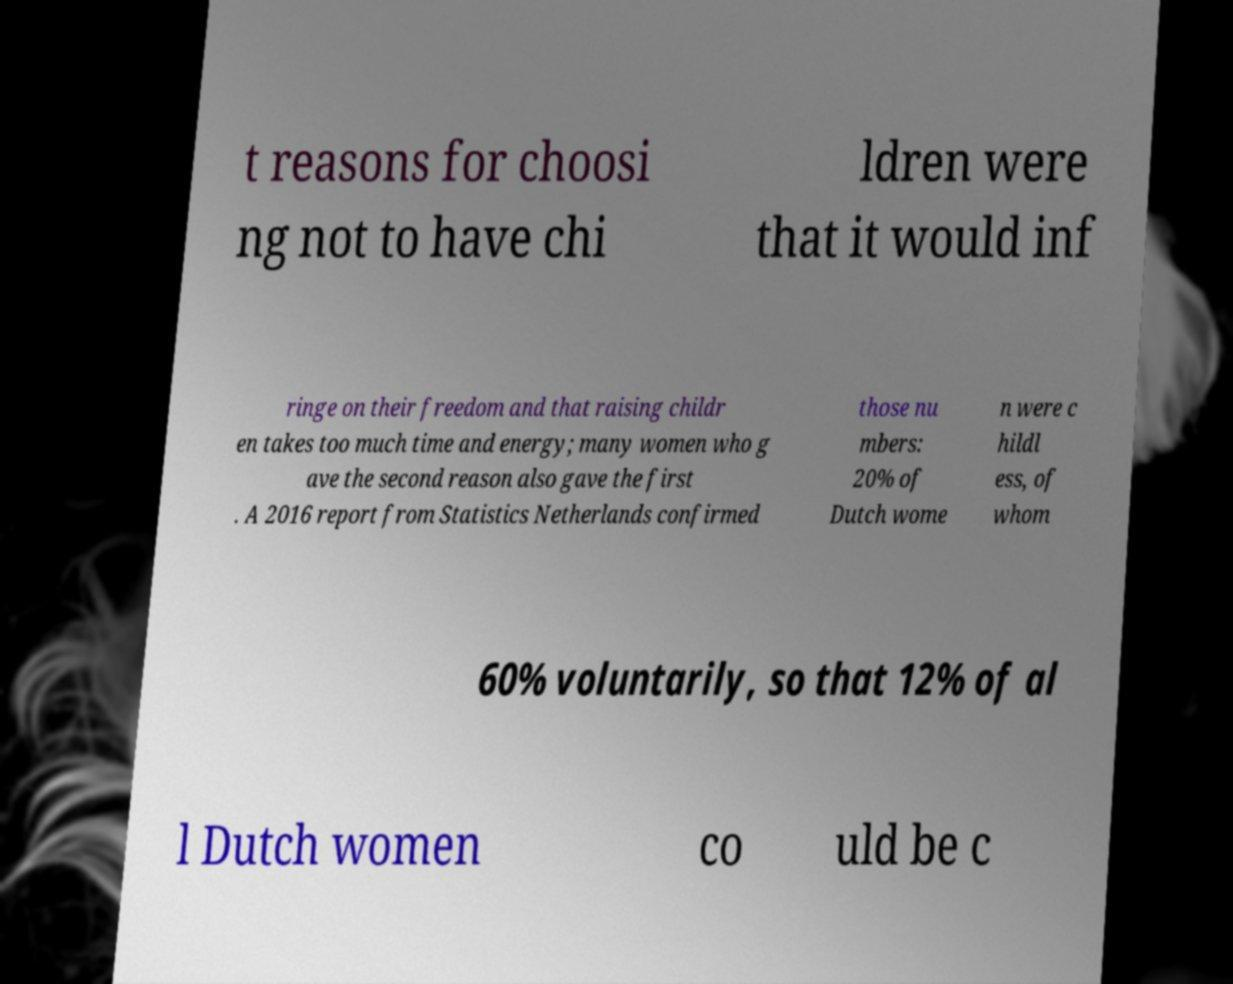Could you assist in decoding the text presented in this image and type it out clearly? t reasons for choosi ng not to have chi ldren were that it would inf ringe on their freedom and that raising childr en takes too much time and energy; many women who g ave the second reason also gave the first . A 2016 report from Statistics Netherlands confirmed those nu mbers: 20% of Dutch wome n were c hildl ess, of whom 60% voluntarily, so that 12% of al l Dutch women co uld be c 